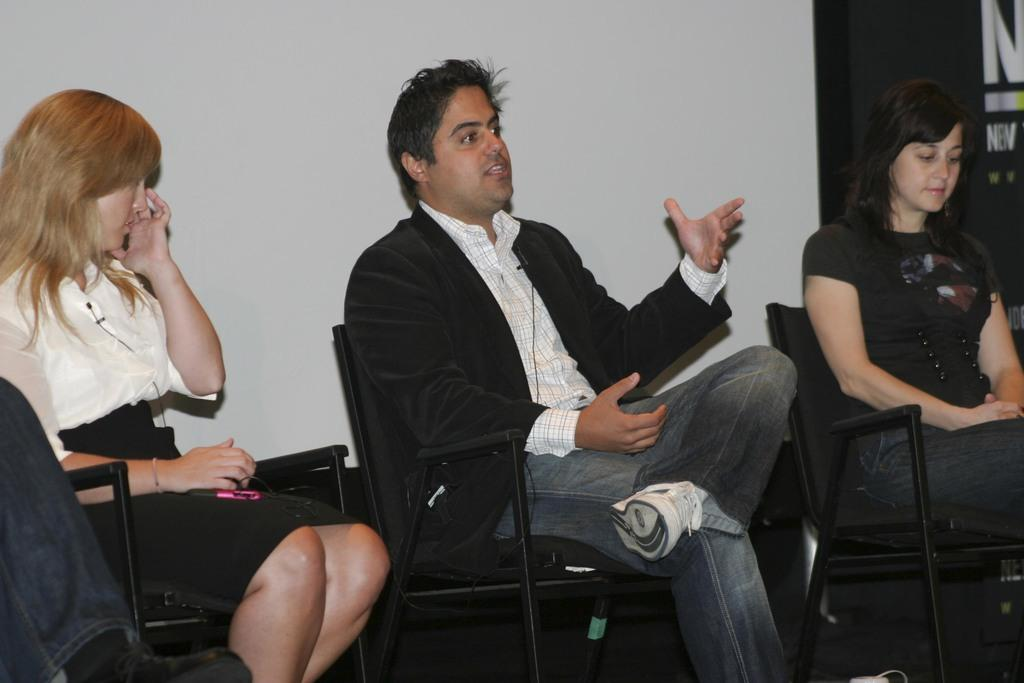What are the people in the image doing? The people in the image are sitting on chairs. Can you describe the woman's location in the image? The woman is near an object in the image. What can be seen in the background of the image? There is a wall and a banner in the background of the image. What type of pets are visible in the image? There are no pets visible in the image. What is the weight of the banner in the image? The weight of the banner cannot be determined from the image alone. 